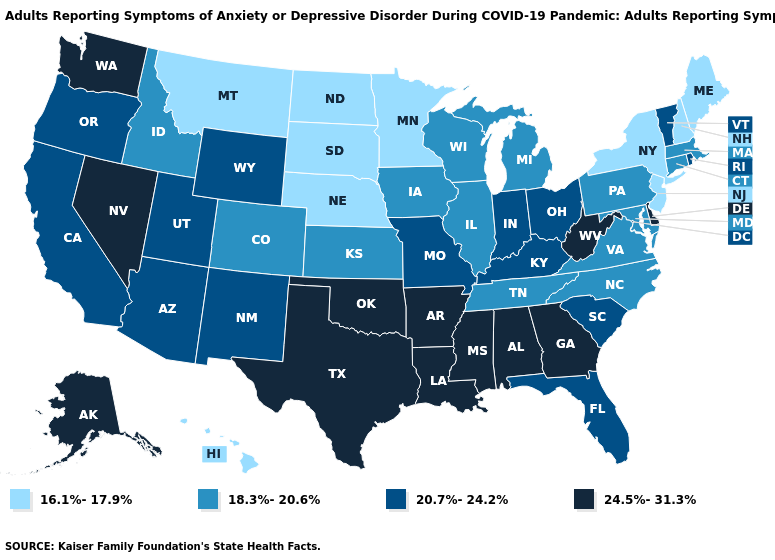What is the value of Idaho?
Write a very short answer. 18.3%-20.6%. Which states have the lowest value in the USA?
Be succinct. Hawaii, Maine, Minnesota, Montana, Nebraska, New Hampshire, New Jersey, New York, North Dakota, South Dakota. What is the value of Ohio?
Quick response, please. 20.7%-24.2%. Which states have the lowest value in the Northeast?
Quick response, please. Maine, New Hampshire, New Jersey, New York. What is the value of Kansas?
Keep it brief. 18.3%-20.6%. Does Maine have the lowest value in the USA?
Quick response, please. Yes. Which states hav the highest value in the South?
Concise answer only. Alabama, Arkansas, Delaware, Georgia, Louisiana, Mississippi, Oklahoma, Texas, West Virginia. Name the states that have a value in the range 24.5%-31.3%?
Give a very brief answer. Alabama, Alaska, Arkansas, Delaware, Georgia, Louisiana, Mississippi, Nevada, Oklahoma, Texas, Washington, West Virginia. What is the lowest value in the USA?
Answer briefly. 16.1%-17.9%. Does Kansas have the same value as North Carolina?
Be succinct. Yes. Which states have the highest value in the USA?
Keep it brief. Alabama, Alaska, Arkansas, Delaware, Georgia, Louisiana, Mississippi, Nevada, Oklahoma, Texas, Washington, West Virginia. What is the value of Wisconsin?
Give a very brief answer. 18.3%-20.6%. Which states have the highest value in the USA?
Concise answer only. Alabama, Alaska, Arkansas, Delaware, Georgia, Louisiana, Mississippi, Nevada, Oklahoma, Texas, Washington, West Virginia. What is the value of Georgia?
Keep it brief. 24.5%-31.3%. What is the highest value in the USA?
Quick response, please. 24.5%-31.3%. 